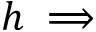<formula> <loc_0><loc_0><loc_500><loc_500>h \implies</formula> 